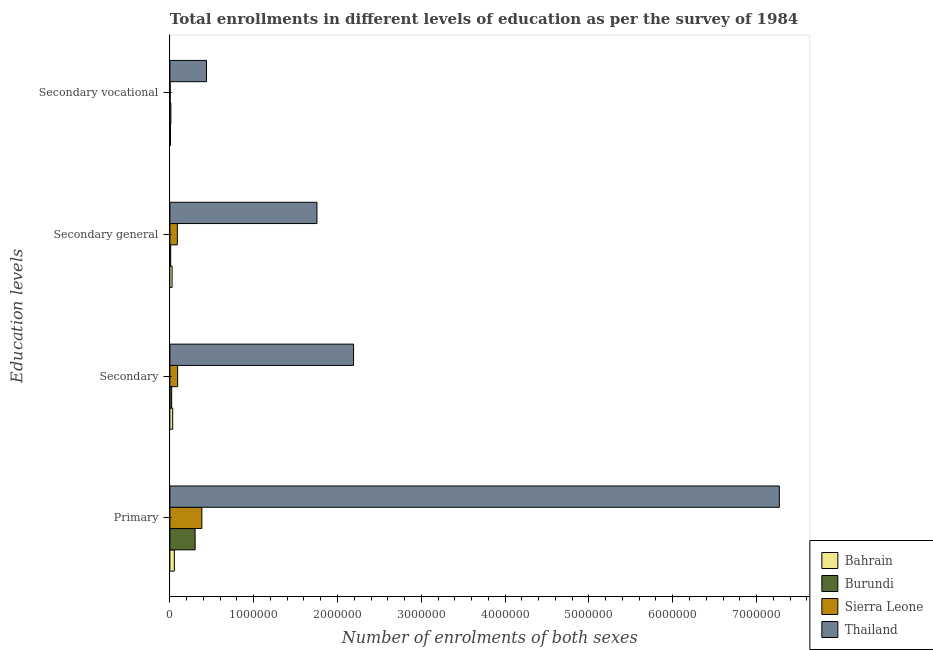How many different coloured bars are there?
Make the answer very short. 4. How many groups of bars are there?
Ensure brevity in your answer.  4. Are the number of bars on each tick of the Y-axis equal?
Provide a succinct answer. Yes. How many bars are there on the 3rd tick from the top?
Offer a very short reply. 4. What is the label of the 1st group of bars from the top?
Ensure brevity in your answer.  Secondary vocational. What is the number of enrolments in secondary education in Thailand?
Keep it short and to the point. 2.19e+06. Across all countries, what is the maximum number of enrolments in secondary education?
Make the answer very short. 2.19e+06. Across all countries, what is the minimum number of enrolments in primary education?
Ensure brevity in your answer.  5.36e+04. In which country was the number of enrolments in secondary general education maximum?
Provide a short and direct response. Thailand. In which country was the number of enrolments in secondary vocational education minimum?
Keep it short and to the point. Sierra Leone. What is the total number of enrolments in secondary general education in the graph?
Provide a succinct answer. 1.88e+06. What is the difference between the number of enrolments in primary education in Sierra Leone and that in Thailand?
Offer a terse response. -6.89e+06. What is the difference between the number of enrolments in secondary education in Sierra Leone and the number of enrolments in secondary general education in Burundi?
Provide a short and direct response. 8.31e+04. What is the average number of enrolments in primary education per country?
Your answer should be compact. 2.00e+06. What is the difference between the number of enrolments in secondary vocational education and number of enrolments in secondary education in Burundi?
Offer a terse response. -9616. What is the ratio of the number of enrolments in secondary vocational education in Sierra Leone to that in Burundi?
Make the answer very short. 0.3. Is the difference between the number of enrolments in secondary general education in Thailand and Sierra Leone greater than the difference between the number of enrolments in primary education in Thailand and Sierra Leone?
Keep it short and to the point. No. What is the difference between the highest and the second highest number of enrolments in primary education?
Provide a succinct answer. 6.89e+06. What is the difference between the highest and the lowest number of enrolments in secondary vocational education?
Make the answer very short. 4.33e+05. In how many countries, is the number of enrolments in secondary education greater than the average number of enrolments in secondary education taken over all countries?
Keep it short and to the point. 1. What does the 4th bar from the top in Secondary general represents?
Ensure brevity in your answer.  Bahrain. What does the 1st bar from the bottom in Secondary general represents?
Your response must be concise. Bahrain. Is it the case that in every country, the sum of the number of enrolments in primary education and number of enrolments in secondary education is greater than the number of enrolments in secondary general education?
Your response must be concise. Yes. Are all the bars in the graph horizontal?
Ensure brevity in your answer.  Yes. How many countries are there in the graph?
Your answer should be compact. 4. What is the difference between two consecutive major ticks on the X-axis?
Your response must be concise. 1.00e+06. Does the graph contain any zero values?
Provide a succinct answer. No. Does the graph contain grids?
Keep it short and to the point. No. How many legend labels are there?
Offer a very short reply. 4. What is the title of the graph?
Give a very brief answer. Total enrollments in different levels of education as per the survey of 1984. What is the label or title of the X-axis?
Give a very brief answer. Number of enrolments of both sexes. What is the label or title of the Y-axis?
Ensure brevity in your answer.  Education levels. What is the Number of enrolments of both sexes of Bahrain in Primary?
Your answer should be compact. 5.36e+04. What is the Number of enrolments of both sexes of Burundi in Primary?
Your answer should be very brief. 3.01e+05. What is the Number of enrolments of both sexes of Sierra Leone in Primary?
Your answer should be compact. 3.82e+05. What is the Number of enrolments of both sexes in Thailand in Primary?
Your response must be concise. 7.27e+06. What is the Number of enrolments of both sexes of Bahrain in Secondary?
Ensure brevity in your answer.  3.35e+04. What is the Number of enrolments of both sexes of Burundi in Secondary?
Offer a very short reply. 2.14e+04. What is the Number of enrolments of both sexes of Sierra Leone in Secondary?
Offer a very short reply. 9.27e+04. What is the Number of enrolments of both sexes in Thailand in Secondary?
Keep it short and to the point. 2.19e+06. What is the Number of enrolments of both sexes of Bahrain in Secondary general?
Offer a terse response. 2.64e+04. What is the Number of enrolments of both sexes in Burundi in Secondary general?
Offer a terse response. 9616. What is the Number of enrolments of both sexes of Sierra Leone in Secondary general?
Offer a terse response. 8.91e+04. What is the Number of enrolments of both sexes in Thailand in Secondary general?
Give a very brief answer. 1.75e+06. What is the Number of enrolments of both sexes in Bahrain in Secondary vocational?
Give a very brief answer. 7067. What is the Number of enrolments of both sexes of Burundi in Secondary vocational?
Ensure brevity in your answer.  1.18e+04. What is the Number of enrolments of both sexes of Sierra Leone in Secondary vocational?
Your answer should be compact. 3589. What is the Number of enrolments of both sexes in Thailand in Secondary vocational?
Provide a succinct answer. 4.37e+05. Across all Education levels, what is the maximum Number of enrolments of both sexes in Bahrain?
Ensure brevity in your answer.  5.36e+04. Across all Education levels, what is the maximum Number of enrolments of both sexes in Burundi?
Your answer should be compact. 3.01e+05. Across all Education levels, what is the maximum Number of enrolments of both sexes of Sierra Leone?
Offer a very short reply. 3.82e+05. Across all Education levels, what is the maximum Number of enrolments of both sexes in Thailand?
Provide a succinct answer. 7.27e+06. Across all Education levels, what is the minimum Number of enrolments of both sexes of Bahrain?
Provide a short and direct response. 7067. Across all Education levels, what is the minimum Number of enrolments of both sexes of Burundi?
Ensure brevity in your answer.  9616. Across all Education levels, what is the minimum Number of enrolments of both sexes in Sierra Leone?
Your answer should be very brief. 3589. Across all Education levels, what is the minimum Number of enrolments of both sexes of Thailand?
Provide a short and direct response. 4.37e+05. What is the total Number of enrolments of both sexes in Bahrain in the graph?
Provide a succinct answer. 1.21e+05. What is the total Number of enrolments of both sexes in Burundi in the graph?
Offer a very short reply. 3.44e+05. What is the total Number of enrolments of both sexes in Sierra Leone in the graph?
Your answer should be very brief. 5.67e+05. What is the total Number of enrolments of both sexes of Thailand in the graph?
Ensure brevity in your answer.  1.17e+07. What is the difference between the Number of enrolments of both sexes of Bahrain in Primary and that in Secondary?
Give a very brief answer. 2.01e+04. What is the difference between the Number of enrolments of both sexes of Burundi in Primary and that in Secondary?
Give a very brief answer. 2.80e+05. What is the difference between the Number of enrolments of both sexes of Sierra Leone in Primary and that in Secondary?
Offer a terse response. 2.89e+05. What is the difference between the Number of enrolments of both sexes in Thailand in Primary and that in Secondary?
Your answer should be compact. 5.08e+06. What is the difference between the Number of enrolments of both sexes in Bahrain in Primary and that in Secondary general?
Your answer should be compact. 2.72e+04. What is the difference between the Number of enrolments of both sexes of Burundi in Primary and that in Secondary general?
Your answer should be compact. 2.92e+05. What is the difference between the Number of enrolments of both sexes in Sierra Leone in Primary and that in Secondary general?
Your answer should be compact. 2.93e+05. What is the difference between the Number of enrolments of both sexes of Thailand in Primary and that in Secondary general?
Provide a succinct answer. 5.52e+06. What is the difference between the Number of enrolments of both sexes in Bahrain in Primary and that in Secondary vocational?
Your answer should be compact. 4.65e+04. What is the difference between the Number of enrolments of both sexes of Burundi in Primary and that in Secondary vocational?
Your answer should be compact. 2.89e+05. What is the difference between the Number of enrolments of both sexes in Sierra Leone in Primary and that in Secondary vocational?
Offer a terse response. 3.78e+05. What is the difference between the Number of enrolments of both sexes of Thailand in Primary and that in Secondary vocational?
Your answer should be very brief. 6.84e+06. What is the difference between the Number of enrolments of both sexes in Bahrain in Secondary and that in Secondary general?
Give a very brief answer. 7067. What is the difference between the Number of enrolments of both sexes of Burundi in Secondary and that in Secondary general?
Give a very brief answer. 1.18e+04. What is the difference between the Number of enrolments of both sexes in Sierra Leone in Secondary and that in Secondary general?
Offer a very short reply. 3589. What is the difference between the Number of enrolments of both sexes in Thailand in Secondary and that in Secondary general?
Give a very brief answer. 4.37e+05. What is the difference between the Number of enrolments of both sexes in Bahrain in Secondary and that in Secondary vocational?
Provide a succinct answer. 2.64e+04. What is the difference between the Number of enrolments of both sexes in Burundi in Secondary and that in Secondary vocational?
Your answer should be very brief. 9616. What is the difference between the Number of enrolments of both sexes in Sierra Leone in Secondary and that in Secondary vocational?
Your response must be concise. 8.91e+04. What is the difference between the Number of enrolments of both sexes in Thailand in Secondary and that in Secondary vocational?
Provide a succinct answer. 1.75e+06. What is the difference between the Number of enrolments of both sexes of Bahrain in Secondary general and that in Secondary vocational?
Your response must be concise. 1.93e+04. What is the difference between the Number of enrolments of both sexes of Burundi in Secondary general and that in Secondary vocational?
Provide a succinct answer. -2192. What is the difference between the Number of enrolments of both sexes in Sierra Leone in Secondary general and that in Secondary vocational?
Provide a short and direct response. 8.55e+04. What is the difference between the Number of enrolments of both sexes in Thailand in Secondary general and that in Secondary vocational?
Give a very brief answer. 1.32e+06. What is the difference between the Number of enrolments of both sexes of Bahrain in Primary and the Number of enrolments of both sexes of Burundi in Secondary?
Your answer should be compact. 3.22e+04. What is the difference between the Number of enrolments of both sexes in Bahrain in Primary and the Number of enrolments of both sexes in Sierra Leone in Secondary?
Provide a succinct answer. -3.91e+04. What is the difference between the Number of enrolments of both sexes of Bahrain in Primary and the Number of enrolments of both sexes of Thailand in Secondary?
Keep it short and to the point. -2.14e+06. What is the difference between the Number of enrolments of both sexes of Burundi in Primary and the Number of enrolments of both sexes of Sierra Leone in Secondary?
Your answer should be very brief. 2.09e+05. What is the difference between the Number of enrolments of both sexes of Burundi in Primary and the Number of enrolments of both sexes of Thailand in Secondary?
Provide a succinct answer. -1.89e+06. What is the difference between the Number of enrolments of both sexes in Sierra Leone in Primary and the Number of enrolments of both sexes in Thailand in Secondary?
Offer a terse response. -1.81e+06. What is the difference between the Number of enrolments of both sexes in Bahrain in Primary and the Number of enrolments of both sexes in Burundi in Secondary general?
Your response must be concise. 4.40e+04. What is the difference between the Number of enrolments of both sexes of Bahrain in Primary and the Number of enrolments of both sexes of Sierra Leone in Secondary general?
Offer a terse response. -3.55e+04. What is the difference between the Number of enrolments of both sexes of Bahrain in Primary and the Number of enrolments of both sexes of Thailand in Secondary general?
Provide a short and direct response. -1.70e+06. What is the difference between the Number of enrolments of both sexes of Burundi in Primary and the Number of enrolments of both sexes of Sierra Leone in Secondary general?
Ensure brevity in your answer.  2.12e+05. What is the difference between the Number of enrolments of both sexes in Burundi in Primary and the Number of enrolments of both sexes in Thailand in Secondary general?
Give a very brief answer. -1.45e+06. What is the difference between the Number of enrolments of both sexes in Sierra Leone in Primary and the Number of enrolments of both sexes in Thailand in Secondary general?
Your answer should be compact. -1.37e+06. What is the difference between the Number of enrolments of both sexes in Bahrain in Primary and the Number of enrolments of both sexes in Burundi in Secondary vocational?
Provide a succinct answer. 4.18e+04. What is the difference between the Number of enrolments of both sexes in Bahrain in Primary and the Number of enrolments of both sexes in Sierra Leone in Secondary vocational?
Keep it short and to the point. 5.00e+04. What is the difference between the Number of enrolments of both sexes in Bahrain in Primary and the Number of enrolments of both sexes in Thailand in Secondary vocational?
Ensure brevity in your answer.  -3.83e+05. What is the difference between the Number of enrolments of both sexes in Burundi in Primary and the Number of enrolments of both sexes in Sierra Leone in Secondary vocational?
Keep it short and to the point. 2.98e+05. What is the difference between the Number of enrolments of both sexes of Burundi in Primary and the Number of enrolments of both sexes of Thailand in Secondary vocational?
Offer a very short reply. -1.36e+05. What is the difference between the Number of enrolments of both sexes in Sierra Leone in Primary and the Number of enrolments of both sexes in Thailand in Secondary vocational?
Provide a short and direct response. -5.51e+04. What is the difference between the Number of enrolments of both sexes of Bahrain in Secondary and the Number of enrolments of both sexes of Burundi in Secondary general?
Provide a short and direct response. 2.39e+04. What is the difference between the Number of enrolments of both sexes of Bahrain in Secondary and the Number of enrolments of both sexes of Sierra Leone in Secondary general?
Offer a terse response. -5.56e+04. What is the difference between the Number of enrolments of both sexes in Bahrain in Secondary and the Number of enrolments of both sexes in Thailand in Secondary general?
Ensure brevity in your answer.  -1.72e+06. What is the difference between the Number of enrolments of both sexes in Burundi in Secondary and the Number of enrolments of both sexes in Sierra Leone in Secondary general?
Offer a very short reply. -6.77e+04. What is the difference between the Number of enrolments of both sexes of Burundi in Secondary and the Number of enrolments of both sexes of Thailand in Secondary general?
Keep it short and to the point. -1.73e+06. What is the difference between the Number of enrolments of both sexes in Sierra Leone in Secondary and the Number of enrolments of both sexes in Thailand in Secondary general?
Ensure brevity in your answer.  -1.66e+06. What is the difference between the Number of enrolments of both sexes of Bahrain in Secondary and the Number of enrolments of both sexes of Burundi in Secondary vocational?
Offer a very short reply. 2.17e+04. What is the difference between the Number of enrolments of both sexes in Bahrain in Secondary and the Number of enrolments of both sexes in Sierra Leone in Secondary vocational?
Give a very brief answer. 2.99e+04. What is the difference between the Number of enrolments of both sexes of Bahrain in Secondary and the Number of enrolments of both sexes of Thailand in Secondary vocational?
Keep it short and to the point. -4.03e+05. What is the difference between the Number of enrolments of both sexes in Burundi in Secondary and the Number of enrolments of both sexes in Sierra Leone in Secondary vocational?
Ensure brevity in your answer.  1.78e+04. What is the difference between the Number of enrolments of both sexes of Burundi in Secondary and the Number of enrolments of both sexes of Thailand in Secondary vocational?
Your response must be concise. -4.15e+05. What is the difference between the Number of enrolments of both sexes in Sierra Leone in Secondary and the Number of enrolments of both sexes in Thailand in Secondary vocational?
Your answer should be very brief. -3.44e+05. What is the difference between the Number of enrolments of both sexes of Bahrain in Secondary general and the Number of enrolments of both sexes of Burundi in Secondary vocational?
Offer a terse response. 1.46e+04. What is the difference between the Number of enrolments of both sexes in Bahrain in Secondary general and the Number of enrolments of both sexes in Sierra Leone in Secondary vocational?
Your answer should be compact. 2.28e+04. What is the difference between the Number of enrolments of both sexes of Bahrain in Secondary general and the Number of enrolments of both sexes of Thailand in Secondary vocational?
Provide a succinct answer. -4.10e+05. What is the difference between the Number of enrolments of both sexes in Burundi in Secondary general and the Number of enrolments of both sexes in Sierra Leone in Secondary vocational?
Give a very brief answer. 6027. What is the difference between the Number of enrolments of both sexes of Burundi in Secondary general and the Number of enrolments of both sexes of Thailand in Secondary vocational?
Ensure brevity in your answer.  -4.27e+05. What is the difference between the Number of enrolments of both sexes in Sierra Leone in Secondary general and the Number of enrolments of both sexes in Thailand in Secondary vocational?
Offer a very short reply. -3.48e+05. What is the average Number of enrolments of both sexes of Bahrain per Education levels?
Offer a terse response. 3.01e+04. What is the average Number of enrolments of both sexes of Burundi per Education levels?
Keep it short and to the point. 8.60e+04. What is the average Number of enrolments of both sexes in Sierra Leone per Education levels?
Ensure brevity in your answer.  1.42e+05. What is the average Number of enrolments of both sexes of Thailand per Education levels?
Give a very brief answer. 2.91e+06. What is the difference between the Number of enrolments of both sexes in Bahrain and Number of enrolments of both sexes in Burundi in Primary?
Make the answer very short. -2.48e+05. What is the difference between the Number of enrolments of both sexes in Bahrain and Number of enrolments of both sexes in Sierra Leone in Primary?
Make the answer very short. -3.28e+05. What is the difference between the Number of enrolments of both sexes of Bahrain and Number of enrolments of both sexes of Thailand in Primary?
Your answer should be very brief. -7.22e+06. What is the difference between the Number of enrolments of both sexes in Burundi and Number of enrolments of both sexes in Sierra Leone in Primary?
Ensure brevity in your answer.  -8.04e+04. What is the difference between the Number of enrolments of both sexes in Burundi and Number of enrolments of both sexes in Thailand in Primary?
Ensure brevity in your answer.  -6.97e+06. What is the difference between the Number of enrolments of both sexes in Sierra Leone and Number of enrolments of both sexes in Thailand in Primary?
Offer a very short reply. -6.89e+06. What is the difference between the Number of enrolments of both sexes in Bahrain and Number of enrolments of both sexes in Burundi in Secondary?
Your response must be concise. 1.21e+04. What is the difference between the Number of enrolments of both sexes of Bahrain and Number of enrolments of both sexes of Sierra Leone in Secondary?
Give a very brief answer. -5.92e+04. What is the difference between the Number of enrolments of both sexes in Bahrain and Number of enrolments of both sexes in Thailand in Secondary?
Give a very brief answer. -2.16e+06. What is the difference between the Number of enrolments of both sexes of Burundi and Number of enrolments of both sexes of Sierra Leone in Secondary?
Give a very brief answer. -7.13e+04. What is the difference between the Number of enrolments of both sexes in Burundi and Number of enrolments of both sexes in Thailand in Secondary?
Provide a short and direct response. -2.17e+06. What is the difference between the Number of enrolments of both sexes of Sierra Leone and Number of enrolments of both sexes of Thailand in Secondary?
Your answer should be compact. -2.10e+06. What is the difference between the Number of enrolments of both sexes of Bahrain and Number of enrolments of both sexes of Burundi in Secondary general?
Make the answer very short. 1.68e+04. What is the difference between the Number of enrolments of both sexes of Bahrain and Number of enrolments of both sexes of Sierra Leone in Secondary general?
Your response must be concise. -6.27e+04. What is the difference between the Number of enrolments of both sexes in Bahrain and Number of enrolments of both sexes in Thailand in Secondary general?
Provide a short and direct response. -1.73e+06. What is the difference between the Number of enrolments of both sexes of Burundi and Number of enrolments of both sexes of Sierra Leone in Secondary general?
Offer a terse response. -7.95e+04. What is the difference between the Number of enrolments of both sexes of Burundi and Number of enrolments of both sexes of Thailand in Secondary general?
Your response must be concise. -1.75e+06. What is the difference between the Number of enrolments of both sexes of Sierra Leone and Number of enrolments of both sexes of Thailand in Secondary general?
Your answer should be compact. -1.67e+06. What is the difference between the Number of enrolments of both sexes of Bahrain and Number of enrolments of both sexes of Burundi in Secondary vocational?
Offer a very short reply. -4741. What is the difference between the Number of enrolments of both sexes of Bahrain and Number of enrolments of both sexes of Sierra Leone in Secondary vocational?
Offer a terse response. 3478. What is the difference between the Number of enrolments of both sexes in Bahrain and Number of enrolments of both sexes in Thailand in Secondary vocational?
Keep it short and to the point. -4.30e+05. What is the difference between the Number of enrolments of both sexes of Burundi and Number of enrolments of both sexes of Sierra Leone in Secondary vocational?
Offer a terse response. 8219. What is the difference between the Number of enrolments of both sexes in Burundi and Number of enrolments of both sexes in Thailand in Secondary vocational?
Ensure brevity in your answer.  -4.25e+05. What is the difference between the Number of enrolments of both sexes in Sierra Leone and Number of enrolments of both sexes in Thailand in Secondary vocational?
Your response must be concise. -4.33e+05. What is the ratio of the Number of enrolments of both sexes in Bahrain in Primary to that in Secondary?
Make the answer very short. 1.6. What is the ratio of the Number of enrolments of both sexes in Burundi in Primary to that in Secondary?
Ensure brevity in your answer.  14.06. What is the ratio of the Number of enrolments of both sexes in Sierra Leone in Primary to that in Secondary?
Ensure brevity in your answer.  4.12. What is the ratio of the Number of enrolments of both sexes of Thailand in Primary to that in Secondary?
Ensure brevity in your answer.  3.32. What is the ratio of the Number of enrolments of both sexes of Bahrain in Primary to that in Secondary general?
Ensure brevity in your answer.  2.03. What is the ratio of the Number of enrolments of both sexes in Burundi in Primary to that in Secondary general?
Make the answer very short. 31.33. What is the ratio of the Number of enrolments of both sexes in Sierra Leone in Primary to that in Secondary general?
Your response must be concise. 4.28. What is the ratio of the Number of enrolments of both sexes of Thailand in Primary to that in Secondary general?
Your answer should be compact. 4.14. What is the ratio of the Number of enrolments of both sexes in Bahrain in Primary to that in Secondary vocational?
Your response must be concise. 7.58. What is the ratio of the Number of enrolments of both sexes of Burundi in Primary to that in Secondary vocational?
Provide a short and direct response. 25.51. What is the ratio of the Number of enrolments of both sexes of Sierra Leone in Primary to that in Secondary vocational?
Ensure brevity in your answer.  106.35. What is the ratio of the Number of enrolments of both sexes of Thailand in Primary to that in Secondary vocational?
Ensure brevity in your answer.  16.65. What is the ratio of the Number of enrolments of both sexes of Bahrain in Secondary to that in Secondary general?
Give a very brief answer. 1.27. What is the ratio of the Number of enrolments of both sexes in Burundi in Secondary to that in Secondary general?
Your answer should be very brief. 2.23. What is the ratio of the Number of enrolments of both sexes in Sierra Leone in Secondary to that in Secondary general?
Give a very brief answer. 1.04. What is the ratio of the Number of enrolments of both sexes of Thailand in Secondary to that in Secondary general?
Ensure brevity in your answer.  1.25. What is the ratio of the Number of enrolments of both sexes of Bahrain in Secondary to that in Secondary vocational?
Your answer should be very brief. 4.74. What is the ratio of the Number of enrolments of both sexes of Burundi in Secondary to that in Secondary vocational?
Offer a terse response. 1.81. What is the ratio of the Number of enrolments of both sexes in Sierra Leone in Secondary to that in Secondary vocational?
Your answer should be compact. 25.83. What is the ratio of the Number of enrolments of both sexes in Thailand in Secondary to that in Secondary vocational?
Offer a terse response. 5.02. What is the ratio of the Number of enrolments of both sexes of Bahrain in Secondary general to that in Secondary vocational?
Make the answer very short. 3.74. What is the ratio of the Number of enrolments of both sexes in Burundi in Secondary general to that in Secondary vocational?
Ensure brevity in your answer.  0.81. What is the ratio of the Number of enrolments of both sexes of Sierra Leone in Secondary general to that in Secondary vocational?
Ensure brevity in your answer.  24.83. What is the ratio of the Number of enrolments of both sexes in Thailand in Secondary general to that in Secondary vocational?
Offer a very short reply. 4.02. What is the difference between the highest and the second highest Number of enrolments of both sexes of Bahrain?
Keep it short and to the point. 2.01e+04. What is the difference between the highest and the second highest Number of enrolments of both sexes of Burundi?
Your response must be concise. 2.80e+05. What is the difference between the highest and the second highest Number of enrolments of both sexes in Sierra Leone?
Your answer should be compact. 2.89e+05. What is the difference between the highest and the second highest Number of enrolments of both sexes of Thailand?
Provide a succinct answer. 5.08e+06. What is the difference between the highest and the lowest Number of enrolments of both sexes of Bahrain?
Offer a terse response. 4.65e+04. What is the difference between the highest and the lowest Number of enrolments of both sexes of Burundi?
Provide a succinct answer. 2.92e+05. What is the difference between the highest and the lowest Number of enrolments of both sexes in Sierra Leone?
Offer a very short reply. 3.78e+05. What is the difference between the highest and the lowest Number of enrolments of both sexes of Thailand?
Keep it short and to the point. 6.84e+06. 